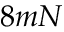<formula> <loc_0><loc_0><loc_500><loc_500>8 m N</formula> 